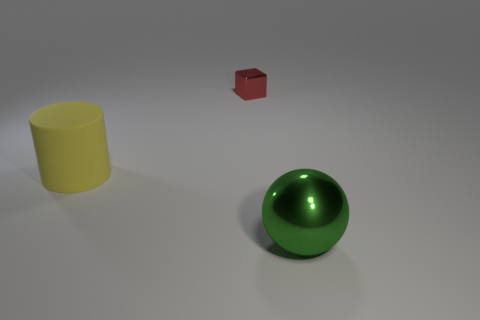Are there any other things that have the same material as the cylinder?
Your answer should be compact. No. What number of other objects are the same shape as the green object?
Your answer should be compact. 0. Is the number of green spheres that are behind the yellow rubber cylinder less than the number of cylinders?
Your response must be concise. Yes. There is a big object that is right of the big cylinder; what material is it?
Your response must be concise. Metal. What number of other objects are there of the same size as the metal ball?
Ensure brevity in your answer.  1. Are there fewer red blocks than yellow metal cubes?
Your answer should be compact. No. What is the shape of the small shiny object?
Your answer should be compact. Cube. The object that is in front of the small cube and behind the big green sphere has what shape?
Your response must be concise. Cylinder. There is a big thing that is left of the green metallic sphere; what color is it?
Your response must be concise. Yellow. Do the green ball and the yellow rubber object have the same size?
Keep it short and to the point. Yes. 